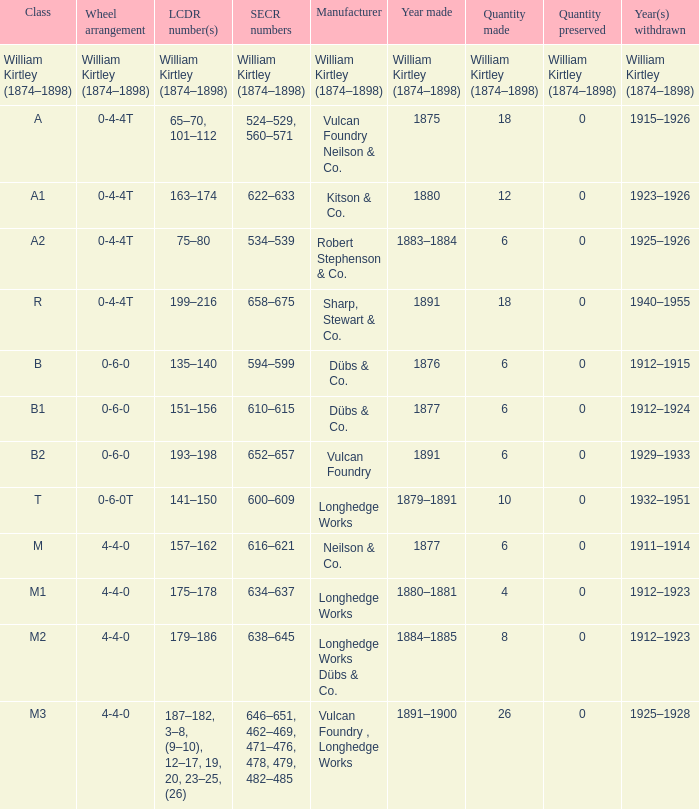Which group was established in 1880? A1. 